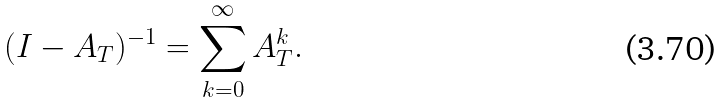<formula> <loc_0><loc_0><loc_500><loc_500>( I - A _ { T } ) ^ { - 1 } = \sum _ { k = 0 } ^ { \infty } A _ { T } ^ { k } .</formula> 